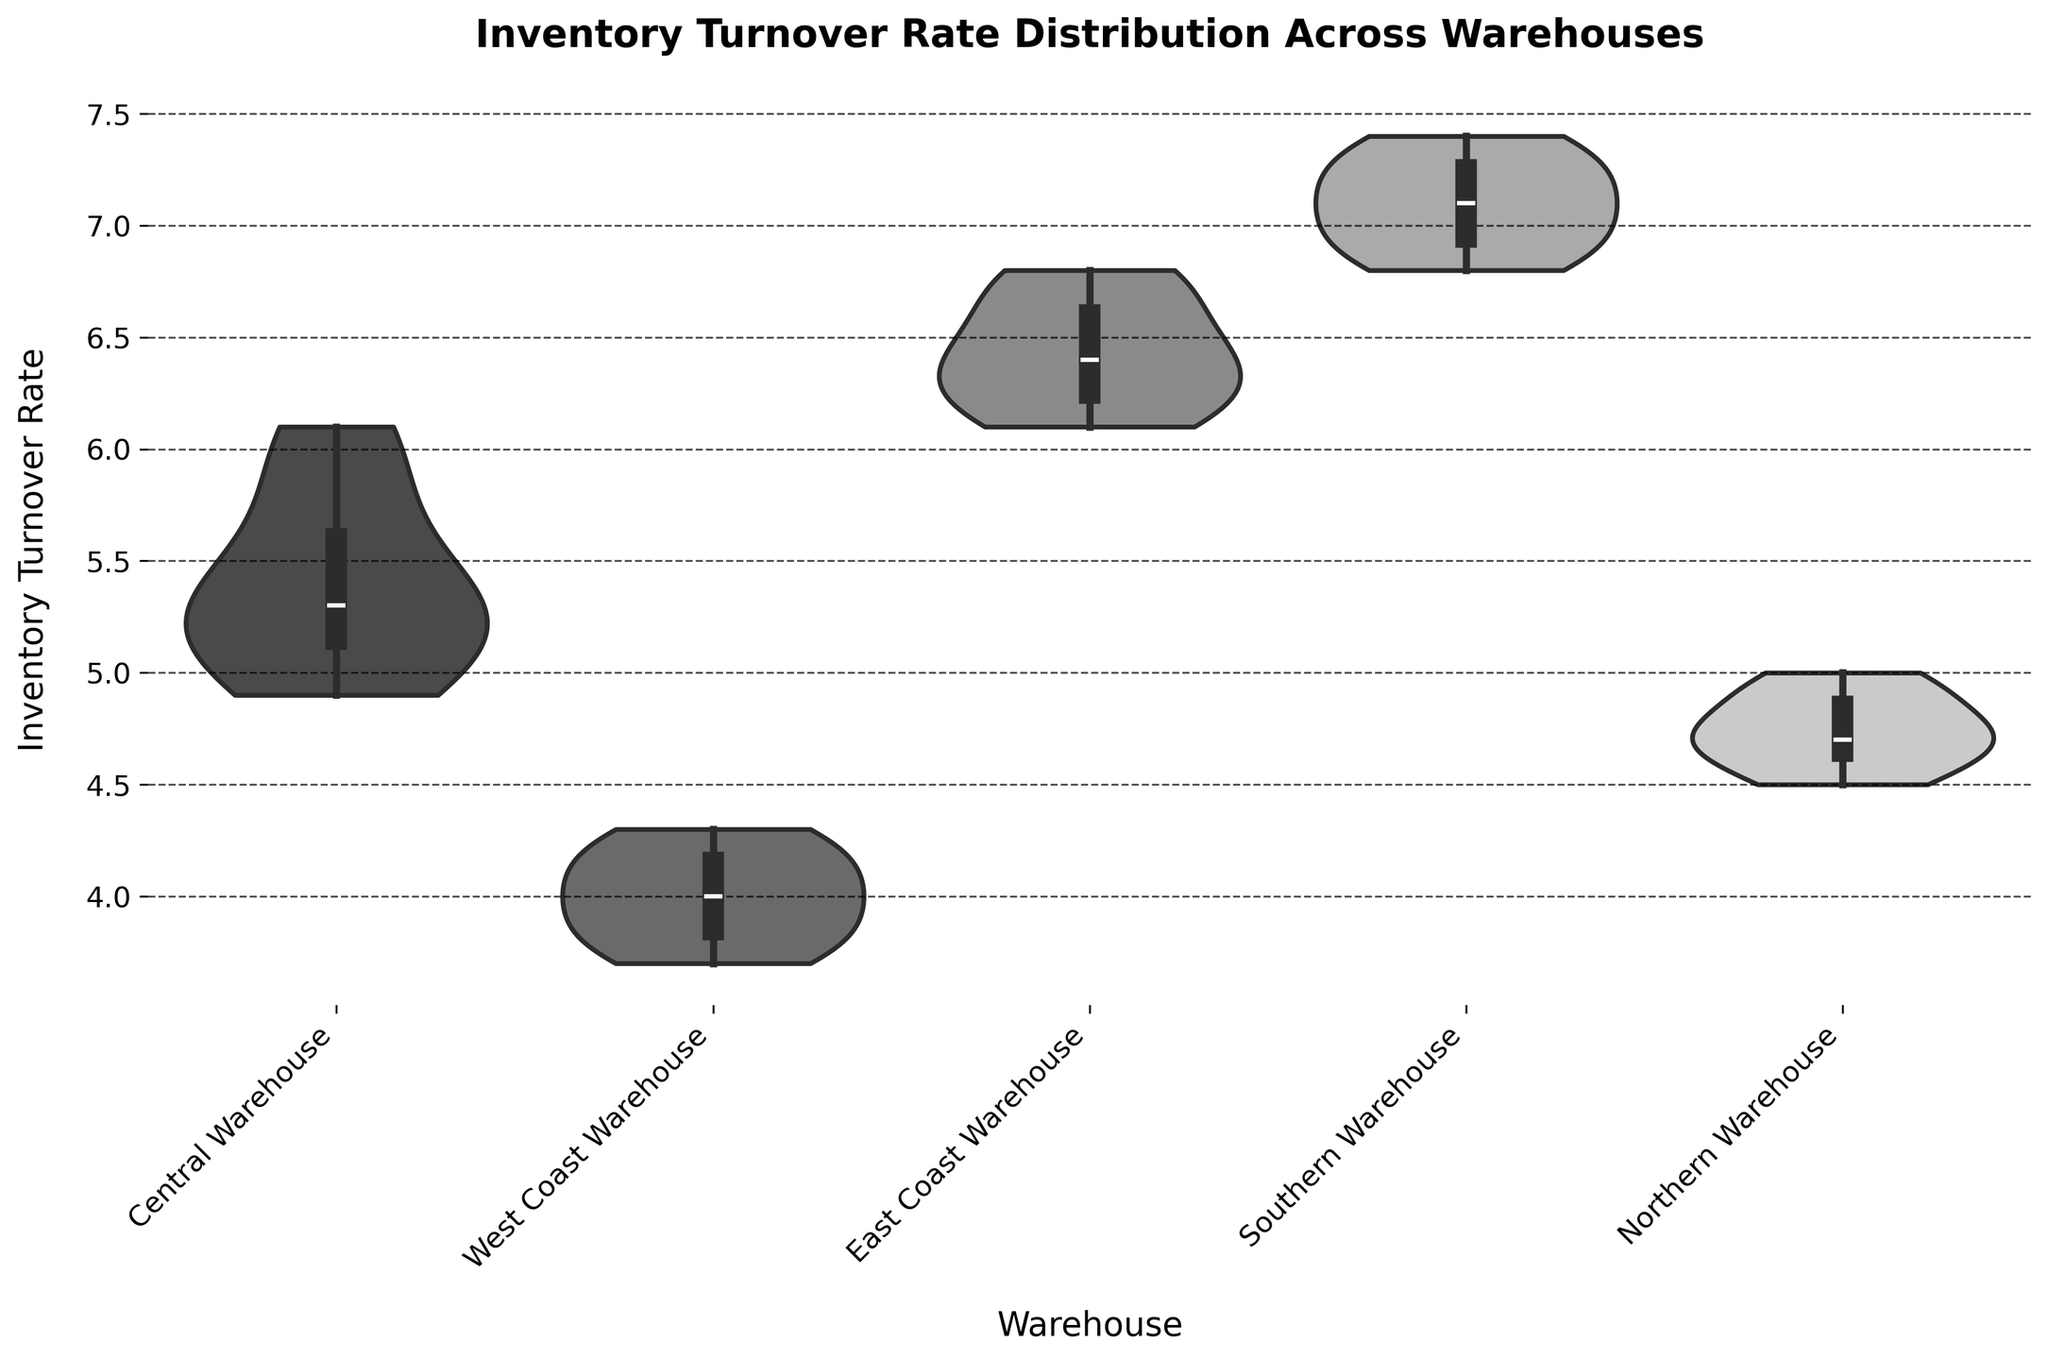What is the title of the figure? The title is located at the top of the figure and typically describes the main theme of the plot. Here, the title reads "Inventory Turnover Rate Distribution Across Warehouses."
Answer: Inventory Turnover Rate Distribution Across Warehouses Which warehouse has the highest median inventory turnover rate? In a violin plot, the white dot inside the violin shape indicates the median value. The Southern Warehouse has the highest median because it's the one with the median positioned the highest on the y-axis.
Answer: Southern Warehouse What is the range of inventory turnover rates for the West Coast Warehouse? The range of the turnover rates can be found by identifying the minimum and maximum points on the y-axis within the distribution for the West Coast Warehouse. For the West Coast Warehouse, the minimum is 3.7, and the maximum is 4.3. Therefore, the range is 4.3 - 3.7.
Answer: 0.6 Which warehouse shows the widest distribution of inventory turnover rates? The width of a violin plot at any vertical position reflects the density of data points. The Southern Warehouse shows the widest and most spread-out distribution, as the shape is both wide and covers a broader range on the y-axis compared to others.
Answer: Southern Warehouse Does the Central Warehouse or the Northern Warehouse have a lower median inventory turnover rate? By comparing the white dots representing the median values in the distribution for both the Central Warehouse and the Northern Warehouse, it's clear that the Northern Warehouse has a lower median.
Answer: Northern Warehouse What is the approximate average inventory turnover rate for the Central Warehouse? The average in a violin plot can roughly be estimated by looking at where the bulk of the data points are centered. For the Central Warehouse, the distribution centers around roughly 5.3 to 5.4.
Answer: Approximately 5.3 to 5.4 How does the density of inventory turnover rates compare between the East Coast and West Coast Warehouses? Comparing the widths of the 'violin' shapes of the East Coast and West Coast Warehouses, the East Coast Warehouse's distribution is more narrow, indicating a higher density around its median, whereas the West Coast Warehouse has a more even distribution but spread over a narrower range.
Answer: The East Coast Warehouse has a higher density; the West Coast has a more even but narrower range Which warehouse has the tightest (narrowest) distribution of inventory turnover rates? The warehouse with the narrowest distribution is identified by the size of the whiteness and density of the violin plot. Central Warehouse’s plot is closest to a tight, narrow distribution without many extreme deviations.
Answer: Central Warehouse What's the difference in the median inventory turnover rate between the East Coast and Southern Warehouses? By looking at the positions of the white dots (medians) in the East Coast and Southern Warehouses, estimating their values as around 6.4 for East Coast and 7.1 for Southern, the difference is 7.1 - 6.4.
Answer: 0.7 